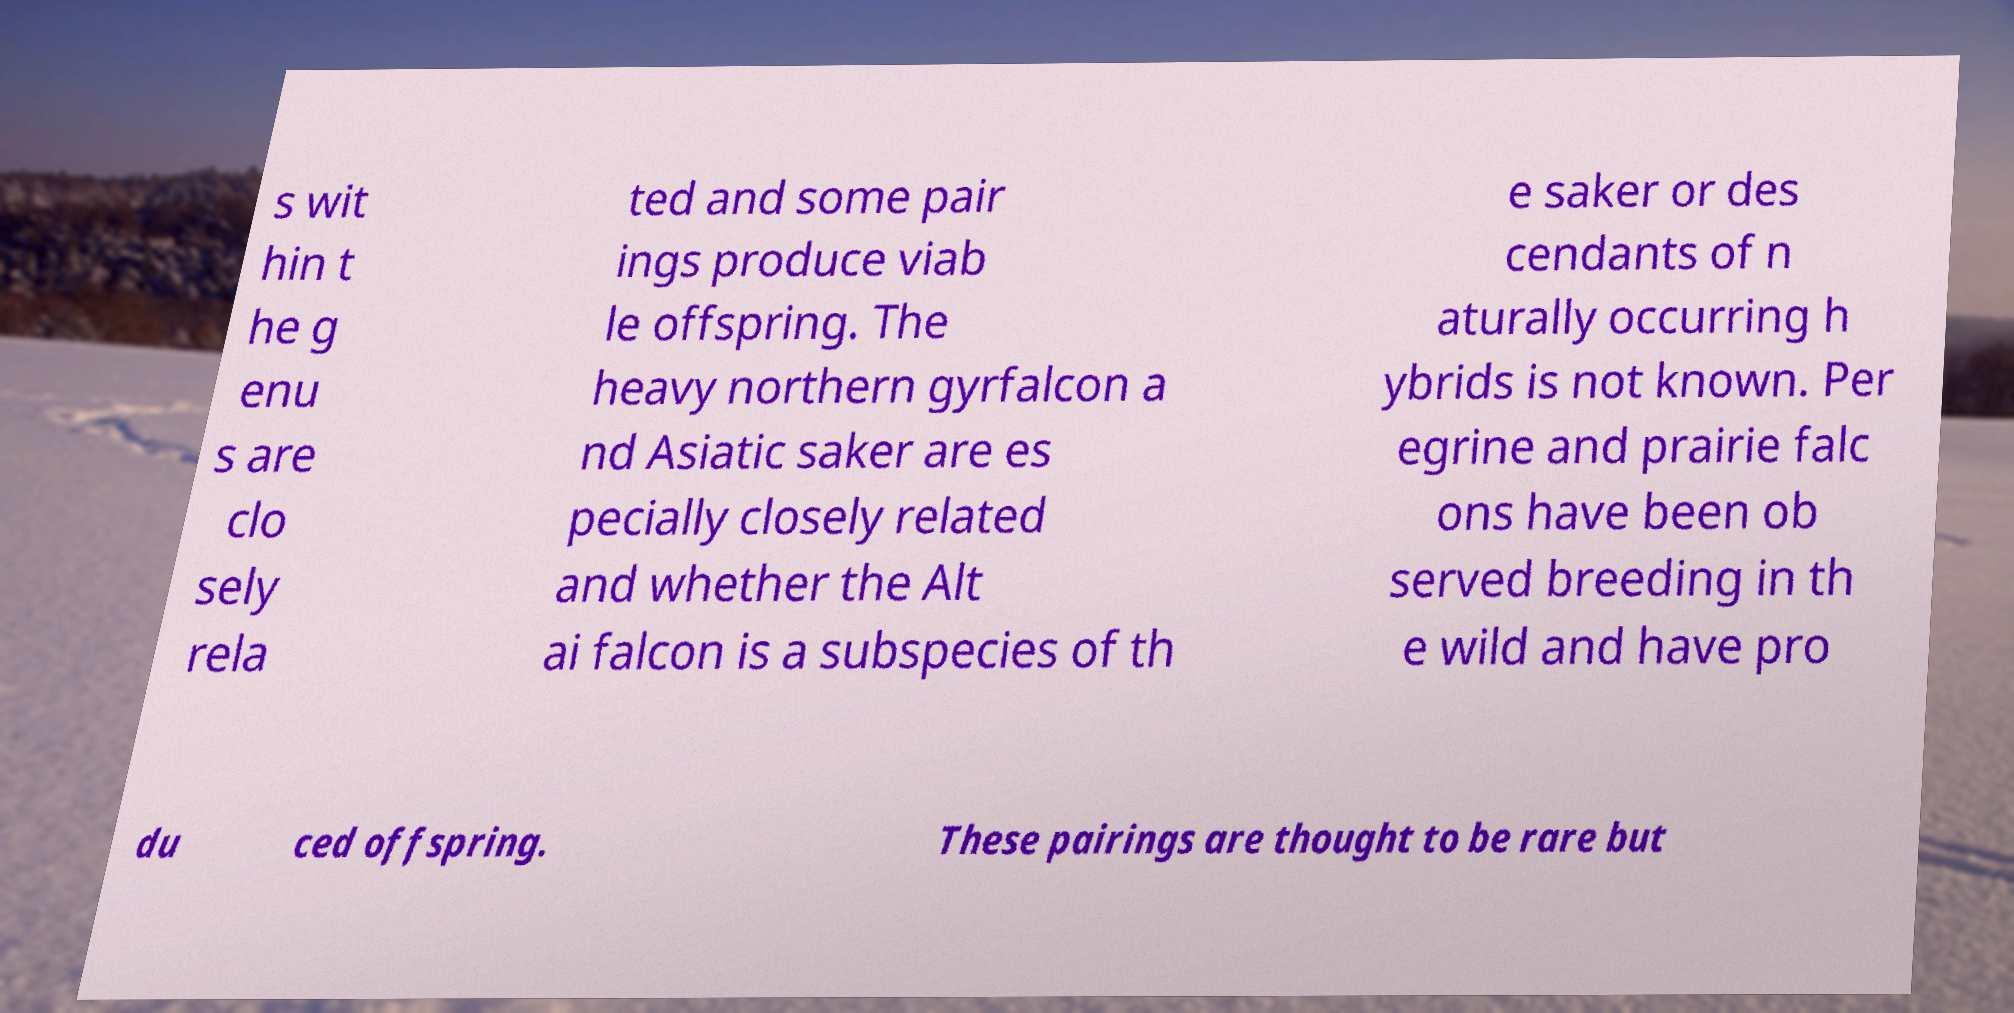There's text embedded in this image that I need extracted. Can you transcribe it verbatim? s wit hin t he g enu s are clo sely rela ted and some pair ings produce viab le offspring. The heavy northern gyrfalcon a nd Asiatic saker are es pecially closely related and whether the Alt ai falcon is a subspecies of th e saker or des cendants of n aturally occurring h ybrids is not known. Per egrine and prairie falc ons have been ob served breeding in th e wild and have pro du ced offspring. These pairings are thought to be rare but 